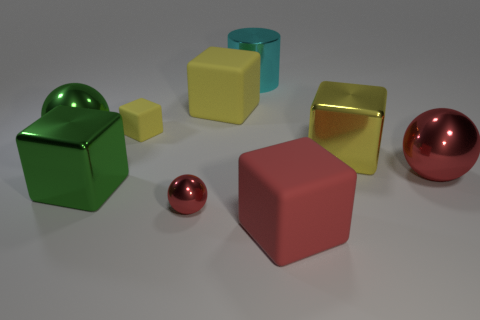What number of large things are matte cubes or cyan metal cylinders?
Offer a very short reply. 3. There is a big metallic sphere that is to the left of the yellow shiny cube; are there any big green metallic objects to the right of it?
Your response must be concise. Yes. Is there a large gray matte sphere?
Your response must be concise. No. The small thing behind the big ball behind the big red metallic thing is what color?
Offer a very short reply. Yellow. There is another tiny object that is the same shape as the red matte object; what is it made of?
Your answer should be very brief. Rubber. How many red objects are the same size as the cyan object?
Provide a short and direct response. 2. There is a green cube that is the same material as the cyan thing; what is its size?
Make the answer very short. Large. How many tiny things are the same shape as the big cyan metallic object?
Provide a short and direct response. 0. How many objects are there?
Your answer should be compact. 9. Do the tiny object that is in front of the tiny yellow block and the big red shiny object have the same shape?
Your answer should be compact. Yes. 